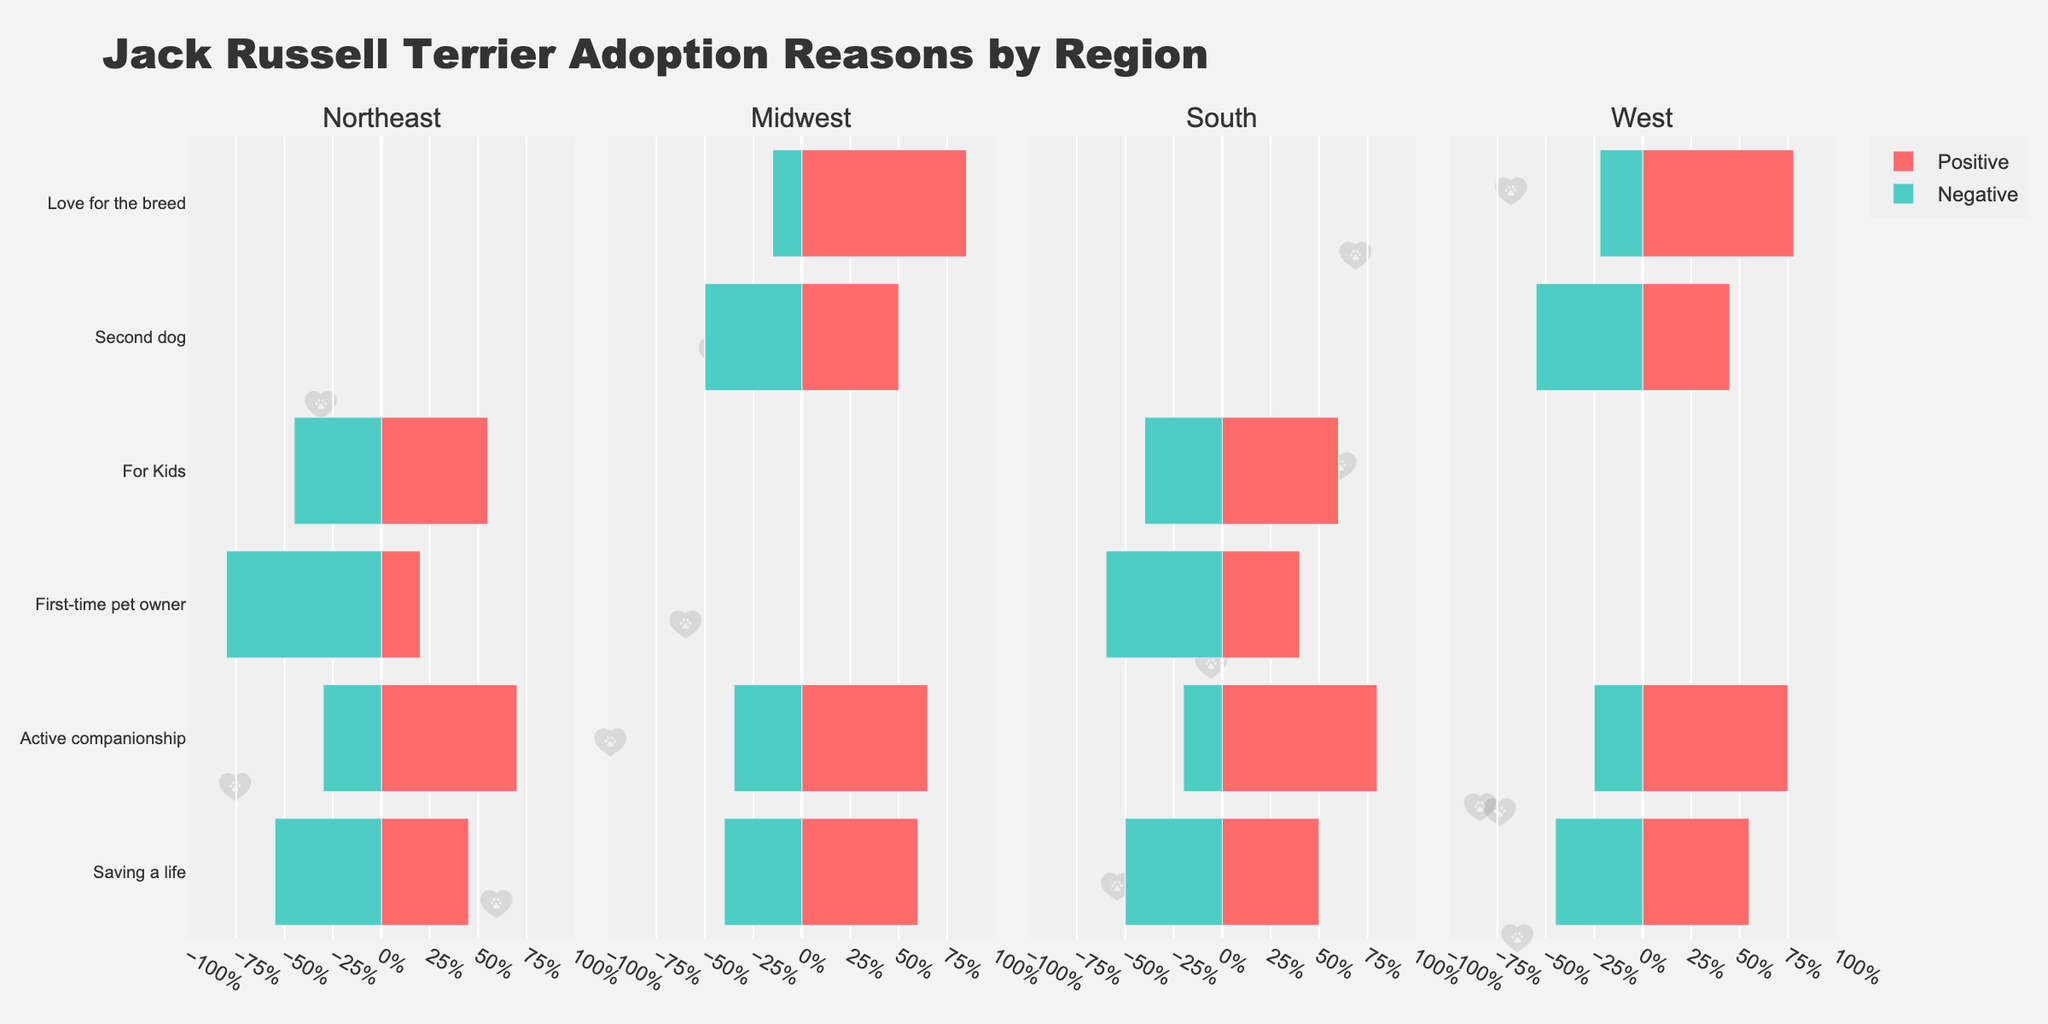What is the most common reason for adopting Jack Russell Terriers in the South based on positive percentages? Look at the South region and compare the positive percentage values for each reason. The highest positive percentage is 80% for "Active companionship".
Answer: Active companionship Which region has the highest negative percentage for first-time pet owners? Compare the negative percentages for the reason "First-time pet owner" across all regions. The highest negative percentage is 80% in the Northeast.
Answer: Northeast What is the combined positive percentage for the reasons "Saving a life" and "Active companionship" in the Midwest? In the Midwest region, "Saving a life" has a positive percentage of 60% and "Active companionship" has a positive percentage of 65%. Adding these together: 60 + 65 = 125.
Answer: 125% Which reason has the smallest difference between positive and negative rates in the West? For each reason in the West, calculate the difference between the positive and negative percentages. "Saving a life" has a positive percentage of 55% and a negative percentage of 45% (difference: 10). "Active companionship" has a difference of 50, "Second dog" has a difference of 10, and "Love for the breed" has a difference of 56. Both "Saving a life" and "Second dog" have the smallest difference, which is 10.
Answer: Saving a life or Second dog Are there more positive adoptions for "For Kids" in the Northeast or South? Compare the positive percentages for "For Kids" in the Northeast (55%) and South (60%). The South has a higher positive percentage.
Answer: South Which region has the highest positive percentage for "Love for the breed"? Compare the positive percentages for "Love for the breed" across all regions. The Midwest has the highest positive percentage with 85%.
Answer: Midwest In the Northeast, what is the difference between the positive percentages for "Active companionship" and the negative percentages for "First-time pet owner"? In the Northeast, "Active companionship" has a positive percentage of 70% and "First-time pet owner" has a negative percentage of 80%. The difference is 70 - (-80) = 150.
Answer: 150% What reason has the highest adoption rate in all regions combined, considering only positive percentages? Sum the positive percentages for each reason across all regions. The reason with the highest sum is the most common. The sums are: Saving a life: 45+60+50+55 = 210, Active companionship: 70+65+80+75 = 290, First-time pet owner: 20+40 = 60, For Kids: 55+60 = 115, Second dog: 50+45 = 95, Love for the breed: 85+78 = 163. "Active companionship" has the highest total positive percentage of 290.
Answer: Active companionship In which region do "Second dog" and "Love for the breed" have almost the same positive percentage? Compare the positive percentages for "Second dog" and "Love for the breed" in each region. In the West, "Second dog" has a positive percentage of 45% and "Love for the breed" has a positive percentage of 78%, which have significant differences. In the Midwest, "Second dog" has a positive percentage of 50% and "Love for the breed" has a positive percentage of 85%, which also have significant differences. Therefore, none of the regions have almost the same positive percentage for these reasons.
Answer: None Which reason has a higher overall negative percentage in both the Midwest and South? Compare the negative percentages for each reason in both the Midwest and South. For "Saving a life": Midwest (40%) and South (50%), "Active companionship": Midwest (35%) and South (20%), "First-time pet owner": South (60%), "Second dog": Midwest (50%) and South (no data), "Love for the breed": Midwest (15%) and South (no data), "For Kids": South (40%). The reason with the higher overall negative percentage in both the Midwest and South is "Saving a life" with 40% in Midwest and 50% in South.
Answer: Saving a life 